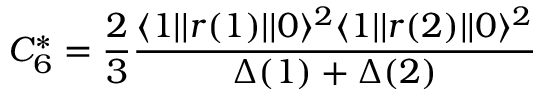Convert formula to latex. <formula><loc_0><loc_0><loc_500><loc_500>C _ { 6 } ^ { * } = \frac { 2 } { 3 } \frac { \langle 1 | | r ( 1 ) | | 0 \rangle ^ { 2 } \langle 1 | | r ( 2 ) | | 0 \rangle ^ { 2 } } { \Delta ( 1 ) + \Delta ( 2 ) }</formula> 